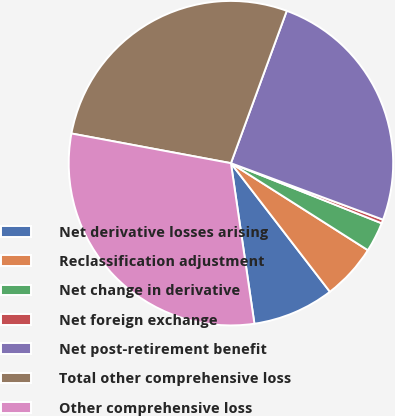Convert chart. <chart><loc_0><loc_0><loc_500><loc_500><pie_chart><fcel>Net derivative losses arising<fcel>Reclassification adjustment<fcel>Net change in derivative<fcel>Net foreign exchange<fcel>Net post-retirement benefit<fcel>Total other comprehensive loss<fcel>Other comprehensive loss<nl><fcel>8.13%<fcel>5.55%<fcel>2.97%<fcel>0.38%<fcel>25.07%<fcel>27.66%<fcel>30.24%<nl></chart> 